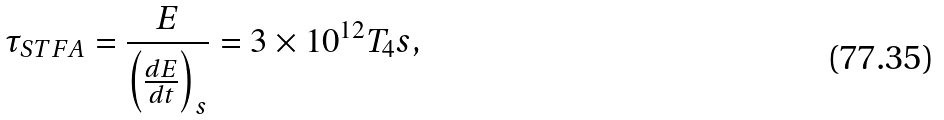<formula> <loc_0><loc_0><loc_500><loc_500>\tau _ { S T F A } = \frac { E } { \left ( \frac { d E } { d t } \right ) _ { s } } = 3 \times 1 0 ^ { 1 2 } T _ { 4 } s ,</formula> 